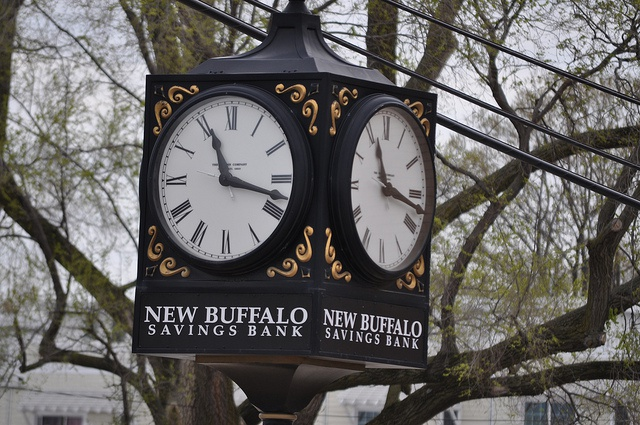Describe the objects in this image and their specific colors. I can see clock in black, darkgray, and gray tones and clock in black, darkgray, and gray tones in this image. 